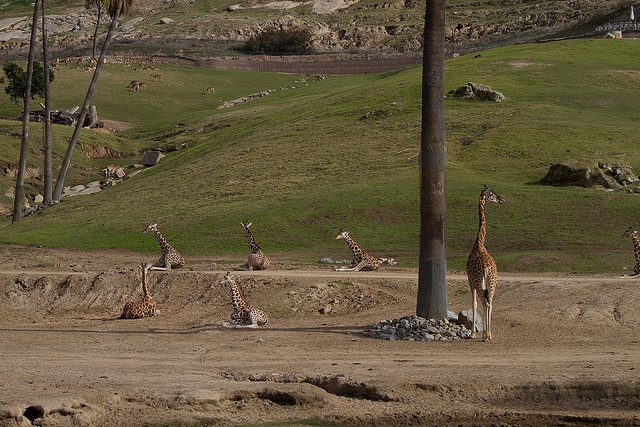Describe the objects in this image and their specific colors. I can see giraffe in darkgreen, black, maroon, and gray tones, giraffe in darkgreen, gray, black, and maroon tones, giraffe in darkgreen, black, gray, and maroon tones, giraffe in darkgreen, black, maroon, gray, and brown tones, and giraffe in darkgreen, black, gray, and maroon tones in this image. 